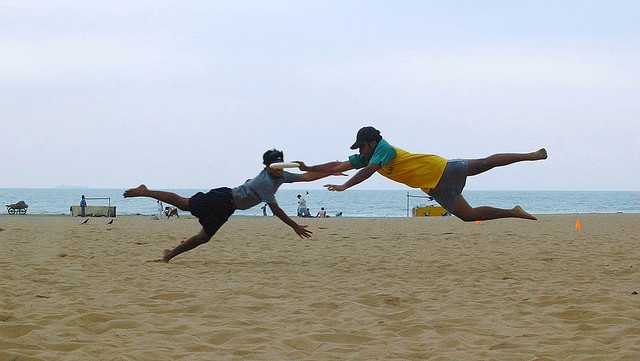Describe the objects in this image and their specific colors. I can see people in lavender, black, maroon, and olive tones, people in lavender, black, maroon, and gray tones, frisbee in lavender, darkgray, gray, and olive tones, people in lavender, gray, darkgray, and black tones, and people in lavender, black, gray, darkgray, and maroon tones in this image. 